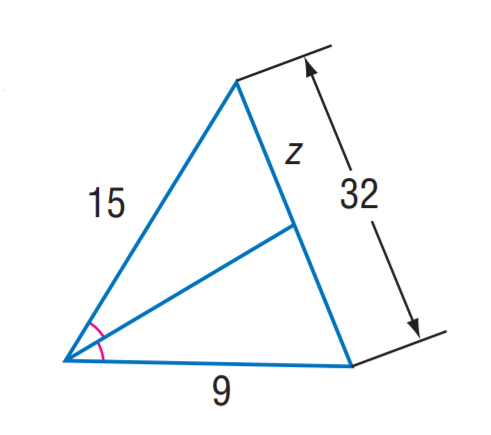Answer the mathemtical geometry problem and directly provide the correct option letter.
Question: Find z.
Choices: A: 15 B: 18 C: 20 D: 24 C 